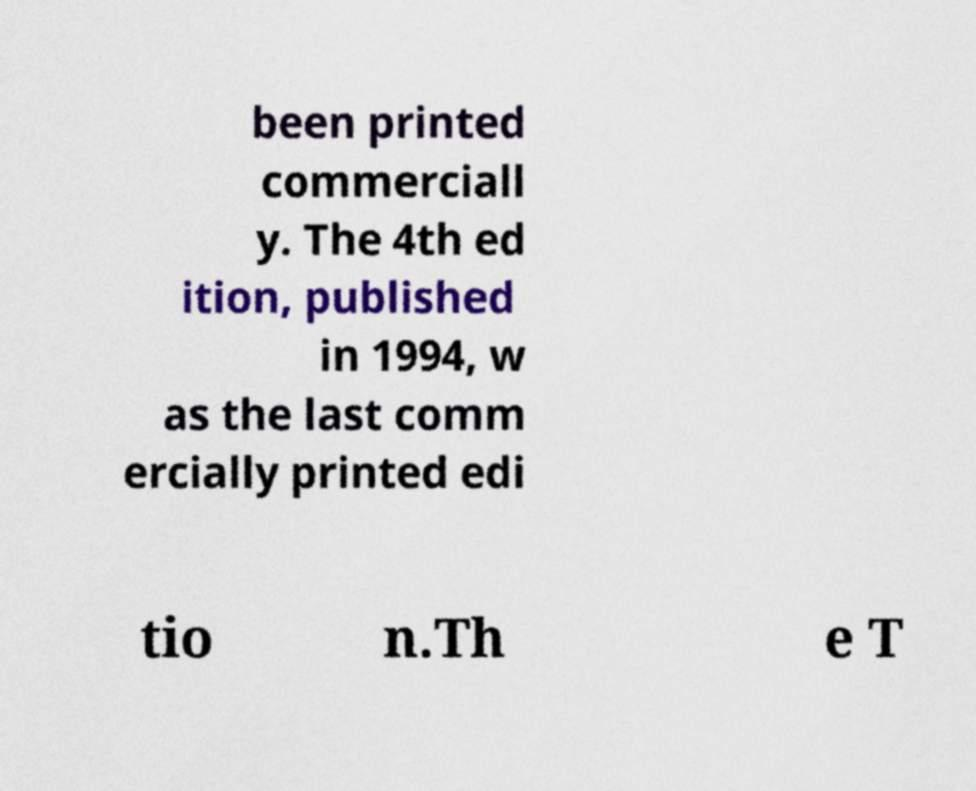There's text embedded in this image that I need extracted. Can you transcribe it verbatim? been printed commerciall y. The 4th ed ition, published in 1994, w as the last comm ercially printed edi tio n.Th e T 